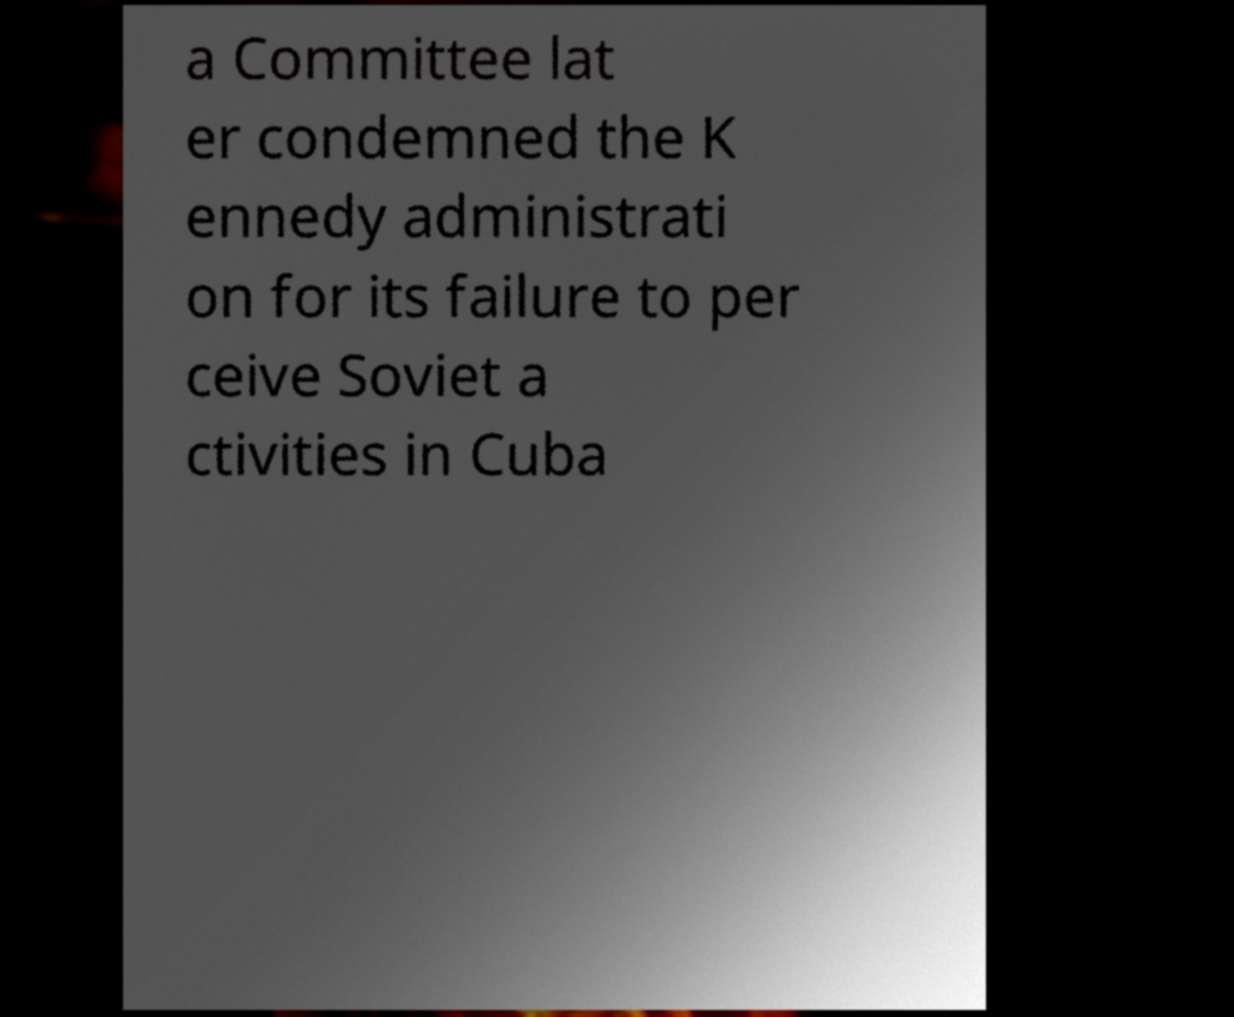Can you accurately transcribe the text from the provided image for me? a Committee lat er condemned the K ennedy administrati on for its failure to per ceive Soviet a ctivities in Cuba 